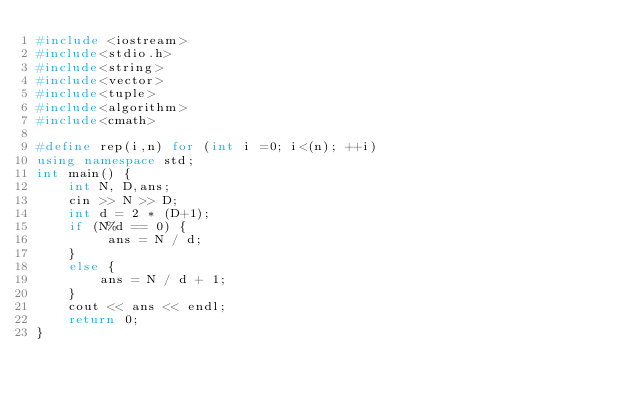<code> <loc_0><loc_0><loc_500><loc_500><_C++_>#include <iostream>
#include<stdio.h>
#include<string>
#include<vector>
#include<tuple>
#include<algorithm>
#include<cmath>

#define rep(i,n) for (int i =0; i<(n); ++i)
using namespace std;
int main() {
	int N, D,ans;
	cin >> N >> D;
	int d = 2 * (D+1);
	if (N%d == 0) {
		 ans = N / d;
	}
	else {
		ans = N / d + 1;
	}
	cout << ans << endl;
	return 0;
}</code> 